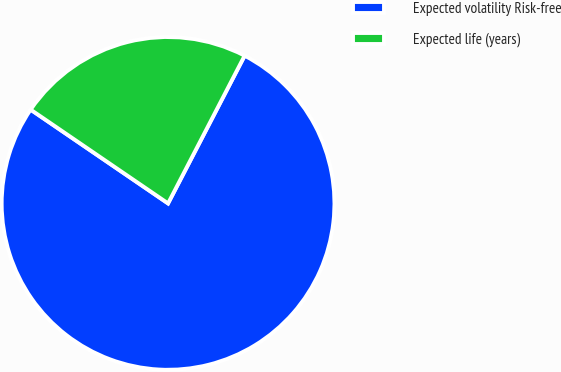<chart> <loc_0><loc_0><loc_500><loc_500><pie_chart><fcel>Expected volatility Risk-free<fcel>Expected life (years)<nl><fcel>76.92%<fcel>23.08%<nl></chart> 